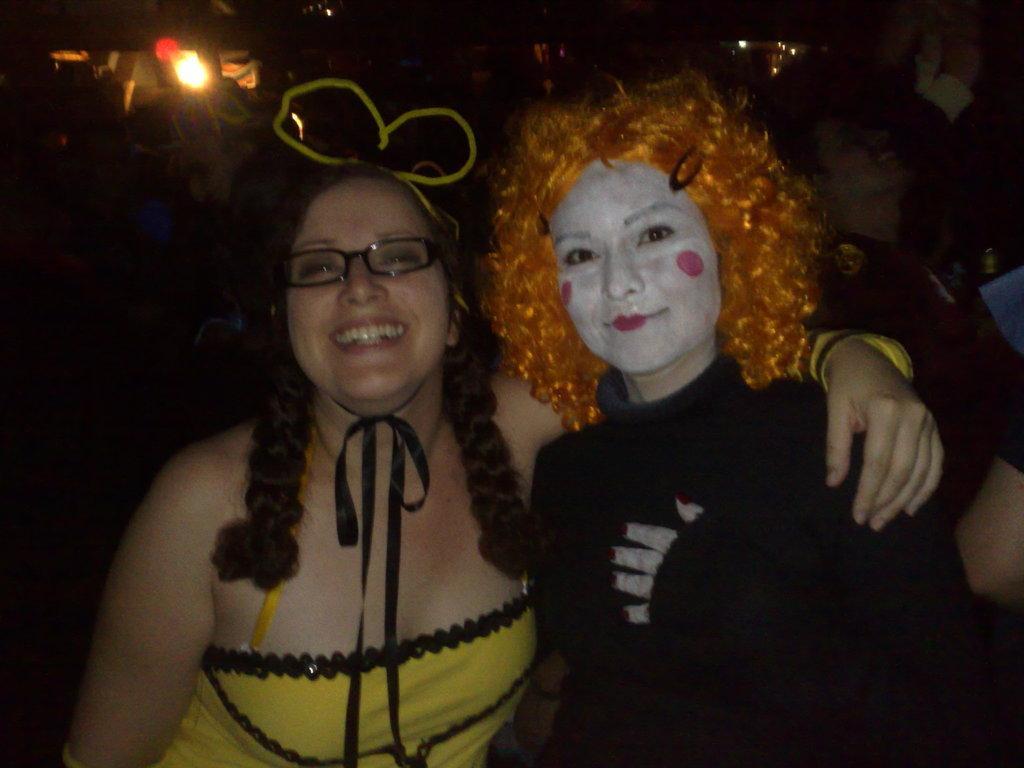Can you describe this image briefly? In this image we can see there are two girls standing with a smile. 